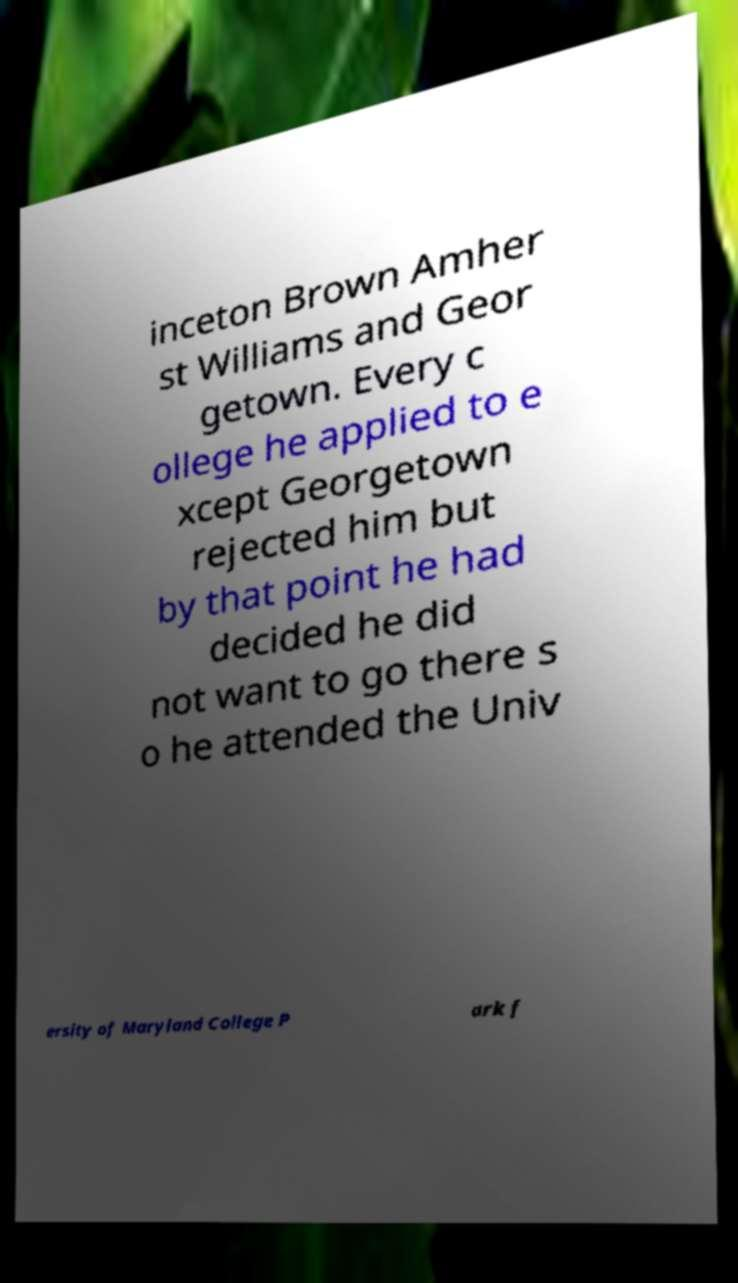Please identify and transcribe the text found in this image. inceton Brown Amher st Williams and Geor getown. Every c ollege he applied to e xcept Georgetown rejected him but by that point he had decided he did not want to go there s o he attended the Univ ersity of Maryland College P ark f 